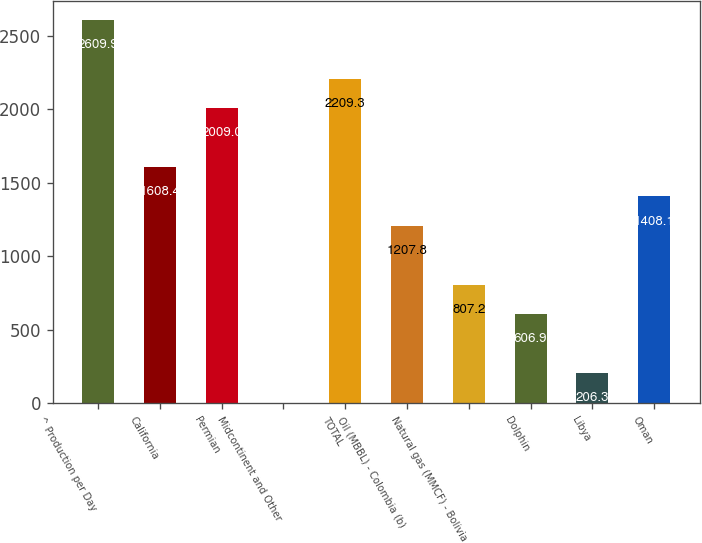<chart> <loc_0><loc_0><loc_500><loc_500><bar_chart><fcel>^ Production per Day<fcel>California<fcel>Permian<fcel>Midcontinent and Other<fcel>TOTAL<fcel>Oil (MBBL) - Colombia (b)<fcel>Natural gas (MMCF) - Bolivia<fcel>Dolphin<fcel>Libya<fcel>Oman<nl><fcel>2609.9<fcel>1608.4<fcel>2009<fcel>6<fcel>2209.3<fcel>1207.8<fcel>807.2<fcel>606.9<fcel>206.3<fcel>1408.1<nl></chart> 